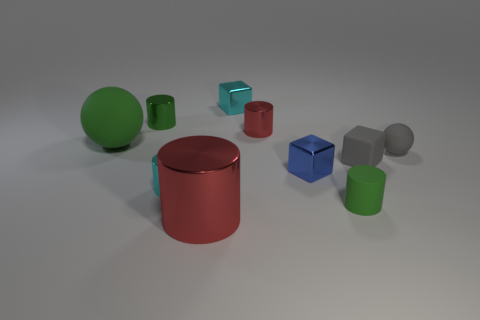Subtract all big cylinders. How many cylinders are left? 4 Subtract all red spheres. How many red cylinders are left? 2 Subtract all green cylinders. How many cylinders are left? 3 Subtract 1 cylinders. How many cylinders are left? 4 Subtract all red blocks. Subtract all red balls. How many blocks are left? 3 Subtract all spheres. How many objects are left? 8 Subtract 1 green cylinders. How many objects are left? 9 Subtract all large red cylinders. Subtract all green metallic things. How many objects are left? 8 Add 8 large cylinders. How many large cylinders are left? 9 Add 6 large things. How many large things exist? 8 